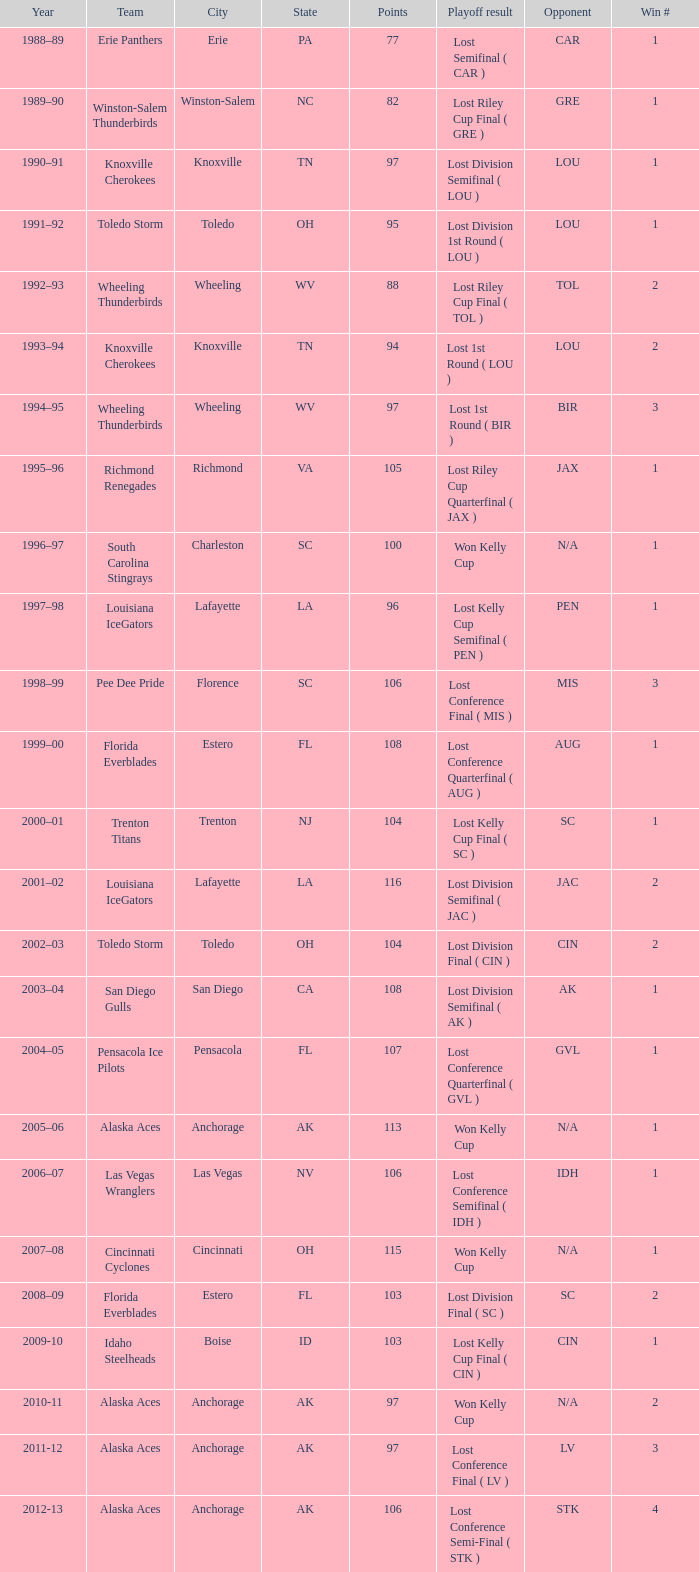What is Winner, when Win # is greater than 1, and when Points is less than 94? Wheeling Thunderbirds. 